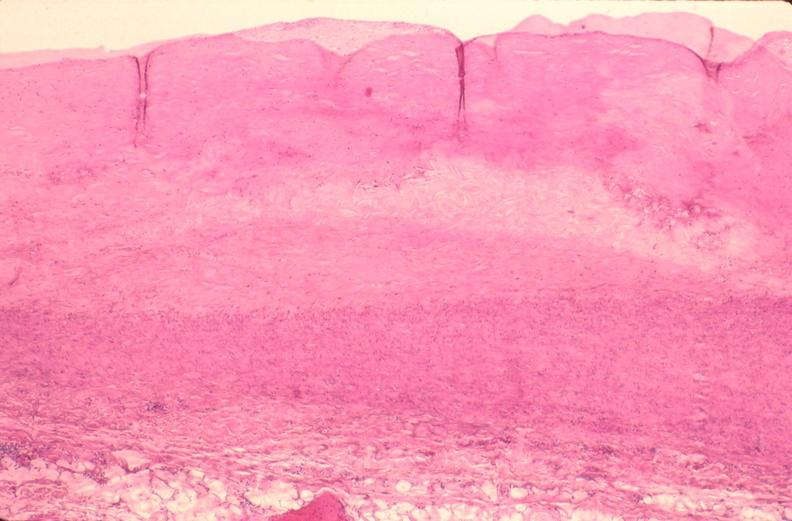what is present?
Answer the question using a single word or phrase. Vasculature 